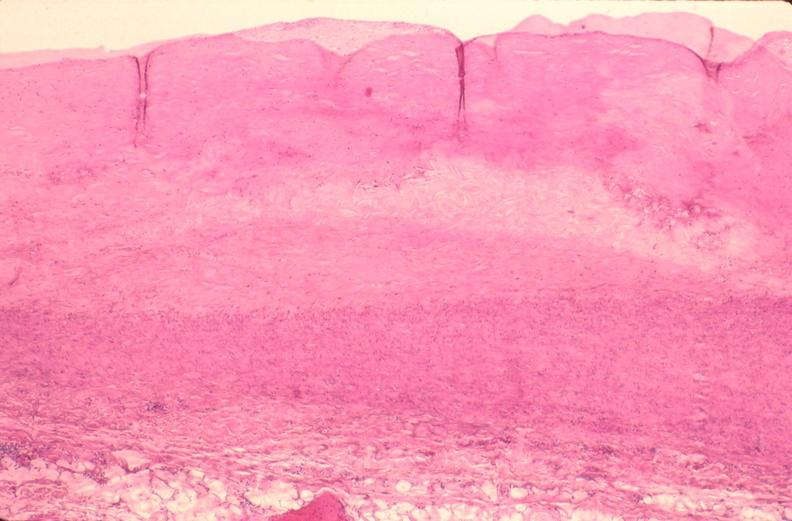what is present?
Answer the question using a single word or phrase. Vasculature 